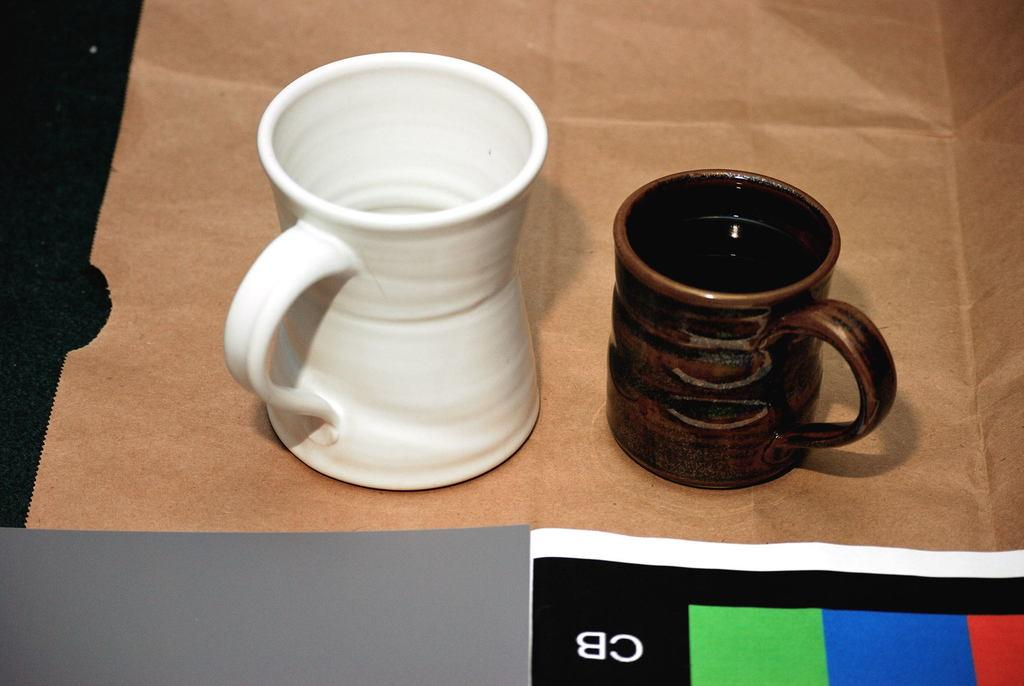<image>
Give a short and clear explanation of the subsequent image. A white mug and a brown mug sit on a brown paper bag in front of a colorful paper with CB on it. 